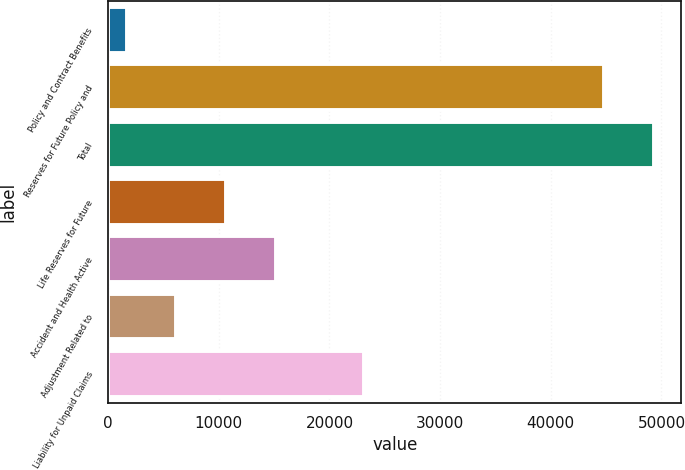Convert chart to OTSL. <chart><loc_0><loc_0><loc_500><loc_500><bar_chart><fcel>Policy and Contract Benefits<fcel>Reserves for Future Policy and<fcel>Total<fcel>Life Reserves for Future<fcel>Accident and Health Active<fcel>Adjustment Related to<fcel>Liability for Unpaid Claims<nl><fcel>1695.7<fcel>44841.9<fcel>49326.1<fcel>10664.1<fcel>15148.3<fcel>6179.89<fcel>23149<nl></chart> 